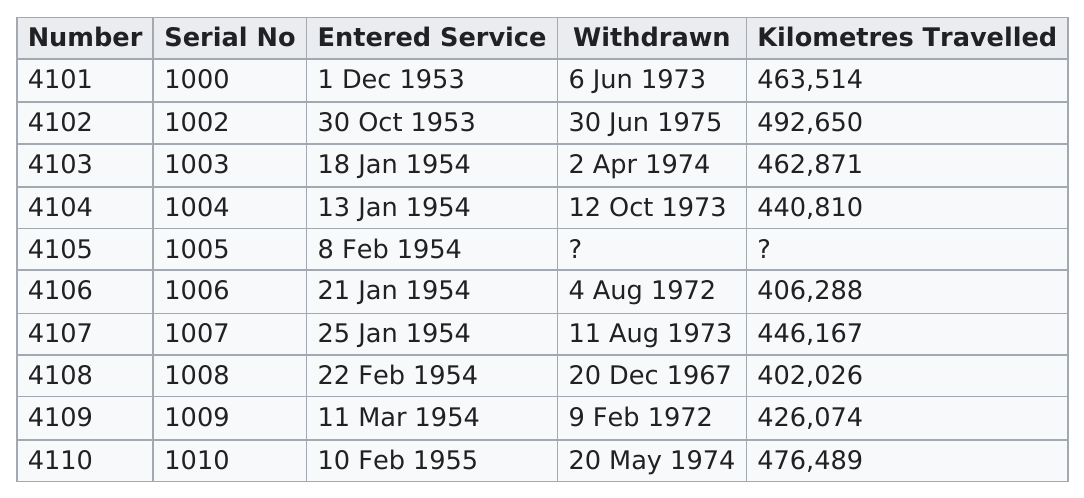Highlight a few significant elements in this photo. The locomotive 4101 was the first to enter into service. The locomotive number 4105 did not have any information available after it entered service. On February 22, 1954, a mere 402,026 kilometres were traveled in a particular service. Number 4110 traveled a total of 476,489 kilometers. The serial numbers 1000, 1002, 1003, 1004, 1007, 1010, and possibly others have travelled more than 440,000 kilometers. 